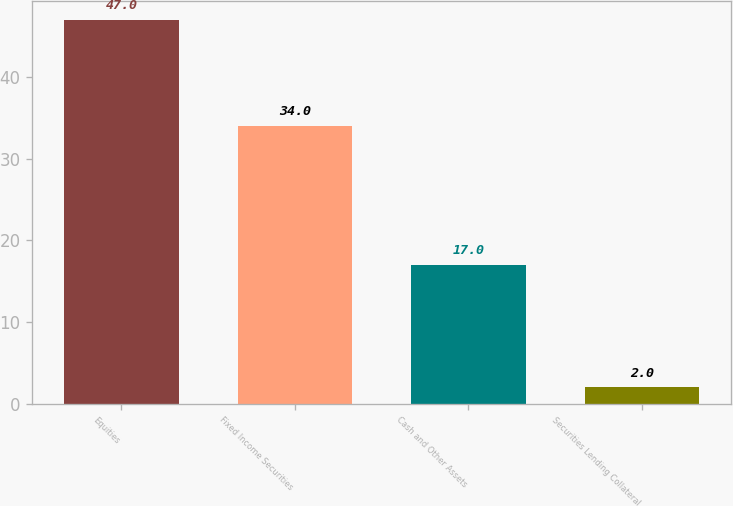Convert chart. <chart><loc_0><loc_0><loc_500><loc_500><bar_chart><fcel>Equities<fcel>Fixed Income Securities<fcel>Cash and Other Assets<fcel>Securities Lending Collateral<nl><fcel>47<fcel>34<fcel>17<fcel>2<nl></chart> 